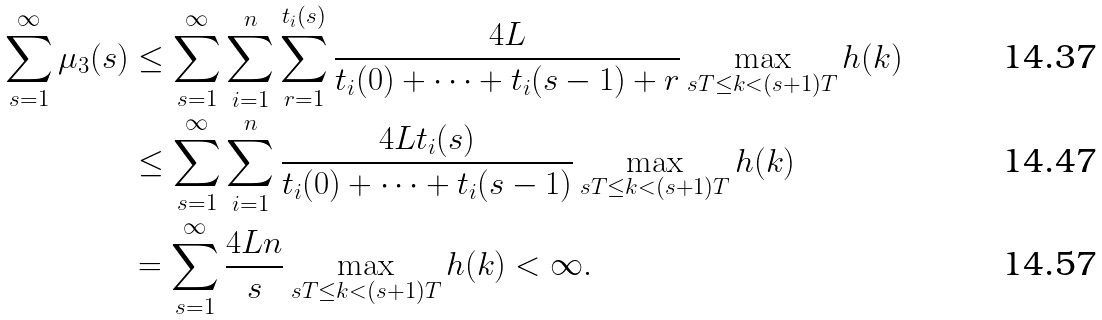Convert formula to latex. <formula><loc_0><loc_0><loc_500><loc_500>\sum ^ { \infty } _ { s = 1 } \mu _ { 3 } ( s ) & \leq \sum ^ { \infty } _ { s = 1 } \sum ^ { n } _ { i = 1 } \sum ^ { t _ { i } ( s ) } _ { r = 1 } \frac { 4 L } { t _ { i } ( 0 ) + \cdots + t _ { i } ( s - 1 ) + r } \max _ { s T \leq k < ( s + 1 ) T } h ( k ) \\ & \leq \sum ^ { \infty } _ { s = 1 } \sum ^ { n } _ { i = 1 } \frac { 4 L t _ { i } ( s ) } { t _ { i } ( 0 ) + \cdots + t _ { i } ( s - 1 ) } \max _ { s T \leq k < ( s + 1 ) T } h ( k ) \\ & = \sum ^ { \infty } _ { s = 1 } \frac { 4 L n } { s } \max _ { s T \leq k < ( s + 1 ) T } h ( k ) < \infty .</formula> 